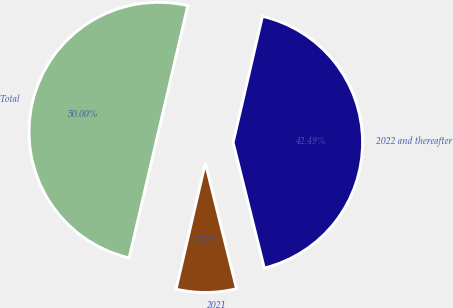<chart> <loc_0><loc_0><loc_500><loc_500><pie_chart><fcel>2021<fcel>2022 and thereafter<fcel>Total<nl><fcel>7.51%<fcel>42.49%<fcel>50.0%<nl></chart> 